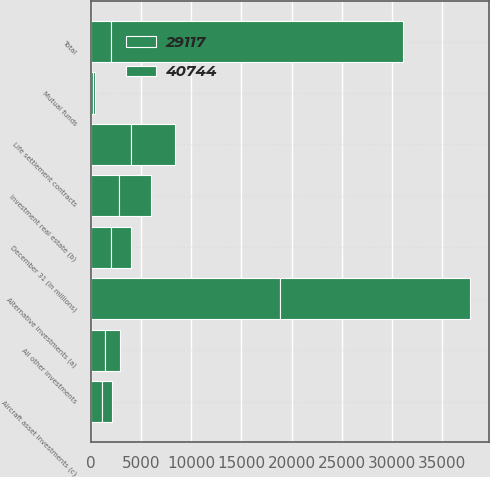Convert chart to OTSL. <chart><loc_0><loc_0><loc_500><loc_500><stacked_bar_chart><ecel><fcel>December 31 (in millions)<fcel>Alternative investments (a)<fcel>Mutual funds<fcel>Investment real estate (b)<fcel>Aircraft asset investments (c)<fcel>Life settlement contracts<fcel>All other investments<fcel>Total<nl><fcel>40744<fcel>2012<fcel>18990<fcel>128<fcel>3195<fcel>984<fcel>4357<fcel>1463<fcel>29117<nl><fcel>29117<fcel>2011<fcel>18793<fcel>258<fcel>2778<fcel>1100<fcel>4006<fcel>1442<fcel>2012<nl></chart> 